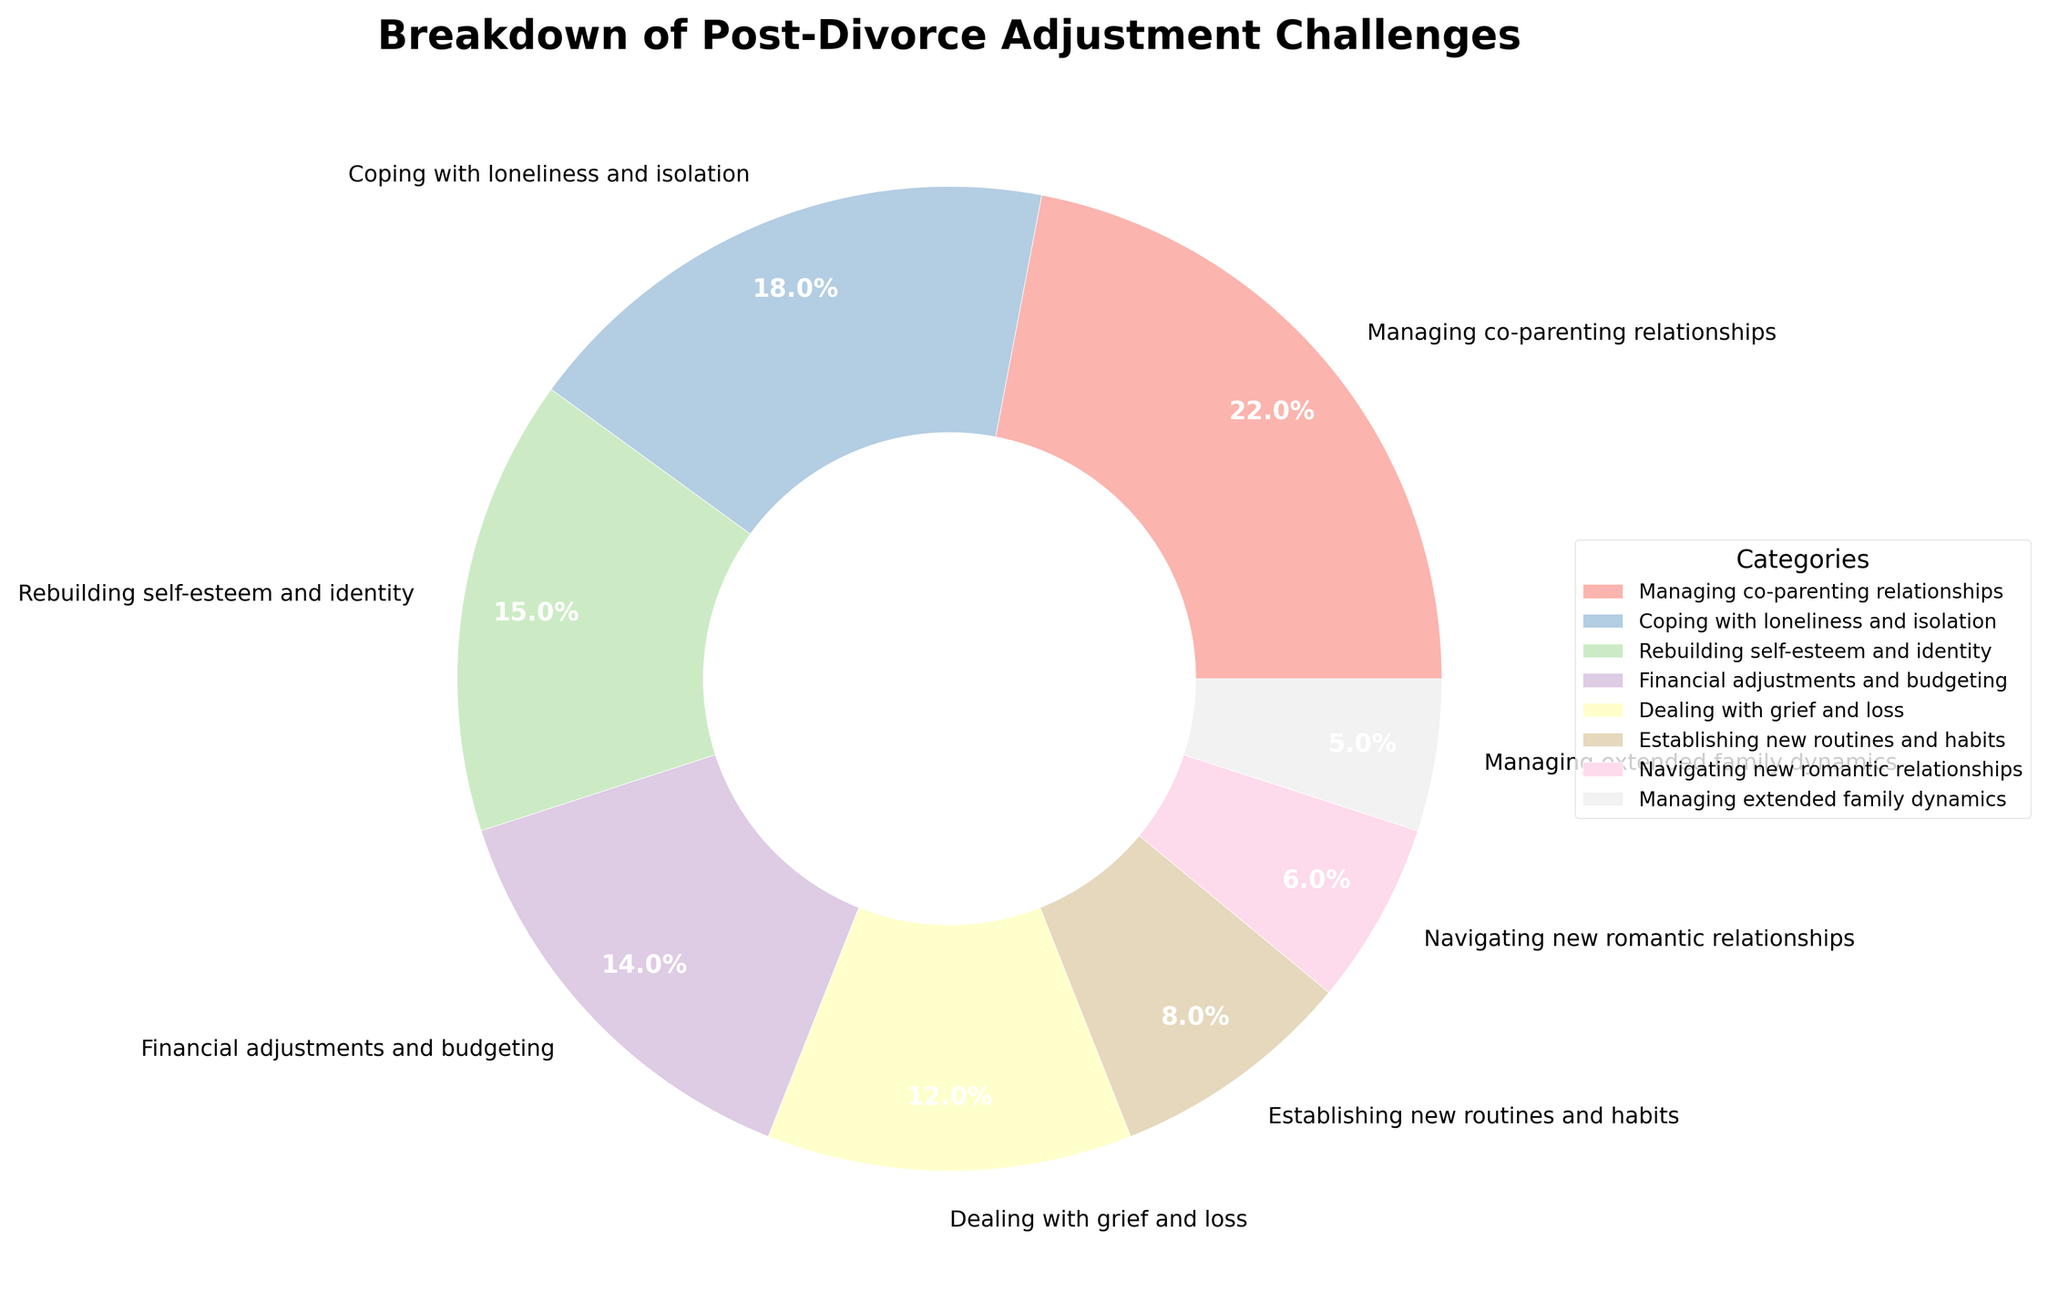Which category is the largest in terms of percentage? The largest percentage can be identified by finding the category with the highest number. In this case, "Managing co-parenting relationships" represents the largest portion at 22%.
Answer: Managing co-parenting relationships What is the combined percentage of "Coping with loneliness and isolation" and "Rebuilding self-esteem and identity"? Add the percentages of "Coping with loneliness and isolation" (18%) and "Rebuilding self-esteem and identity" (15%) to get the combined percentage. 18% + 15% = 33%.
Answer: 33% Which category has a smaller percentage: "Establishing new routines and habits" or "Navigating new romantic relationships"? Compare the two percentages: "Establishing new routines and habits" is at 8%, and "Navigating new romantic relationships" is at 6%. The latter has a smaller percentage.
Answer: Navigating new romantic relationships How much larger is the percentage for "Financial adjustments and budgeting" compared to "Managing extended family dynamics"? Subtract the percentage for "Managing extended family dynamics" (5%) from "Financial adjustments and budgeting" (14%). 14% - 5% = 9%.
Answer: 9% What is the average percentage of the categories that deal with personal emotions and identity (i.e., "Coping with loneliness and isolation," "Rebuilding self-esteem and identity," and "Dealing with grief and loss")? Sum the relevant percentages: 18% + 15% + 12% = 45%. Then divide by the number of categories: 45% / 3 ≈ 15%.
Answer: 15% Which category comes third in terms of percentage, and what is its value? Order the categories by percentage and find the third highest. "Rebuilding self-esteem and identity" is third with 15%.
Answer: Rebuilding self-esteem and identity, 15% What percentage of the post-divorce adjustment challenges are related to establishing new routines and managing external relationships (i.e., "Establishing new routines and habits," "Navigating new romantic relationships," and "Managing extended family dynamics")? Add the percentages of the relevant categories: 8% + 6% + 5% = 19%.
Answer: 19% How does the percentage for "Dealing with grief and loss" compare to the percentage for "Financial adjustments and budgeting"? Compare the two percentages: "Dealing with grief and loss" is at 12%, and "Financial adjustments and budgeting" is at 14%. "Financial adjustments and budgeting" is 2% higher.
Answer: Financial adjustments and budgeting is 2% higher If you combine "Managing co-parenting relationships," "Financial adjustments and budgeting," and "Dealing with grief and loss," what is the cumulative percentage? Sum the percentages: 22% + 14% + 12% = 48%.
Answer: 48% Which category is represented by the pastel color that occupies the smallest portion, and what is its percentage? Identify the smallest wedge visually and check the corresponding category. "Managing extended family dynamics" is the smallest wedge with 5%.
Answer: Managing extended family dynamics, 5% 